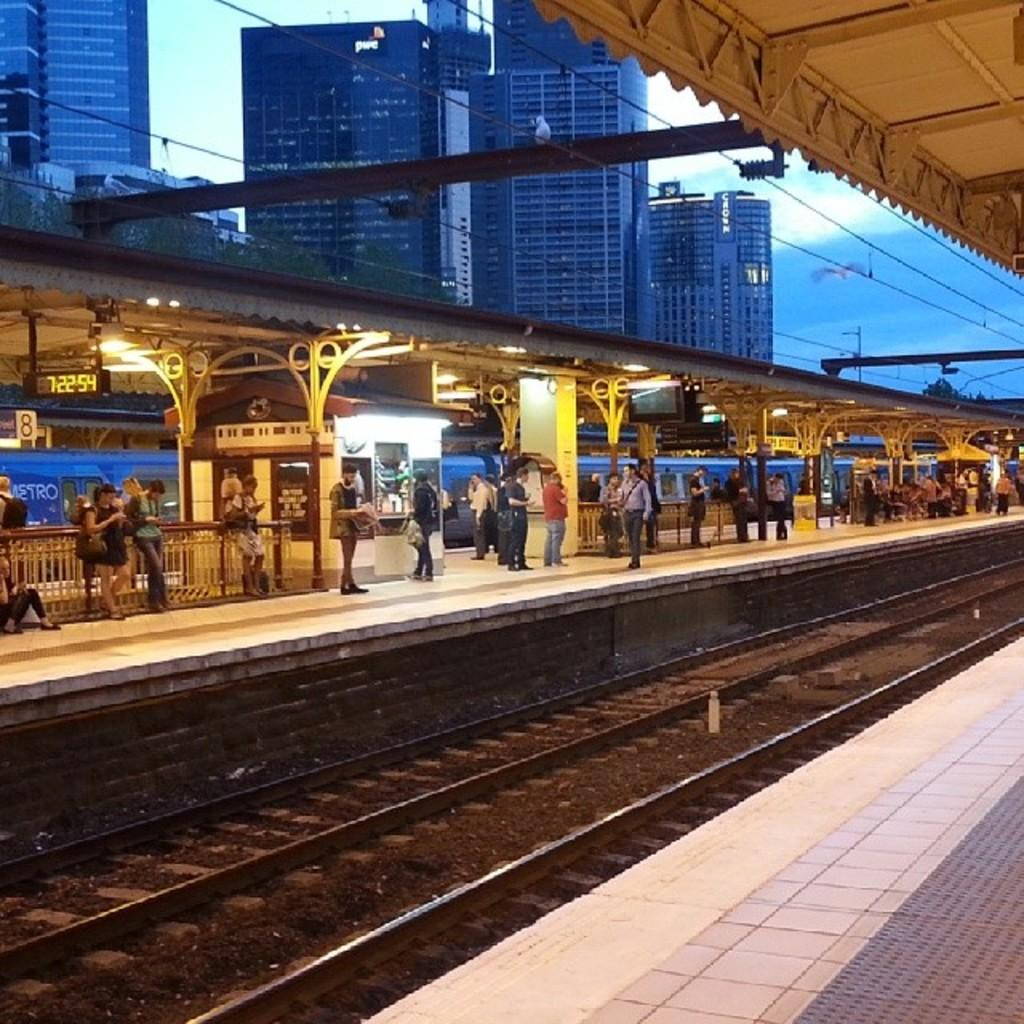How many people are in the image? There is a group of people in the image, but the exact number cannot be determined from the provided facts. What are the people in the image doing? Some people are seated, while others are standing. What can be seen in the background of the image? There are tracks, buildings, cables, and lights visible in the image. What might be used for illumination in the image? Lights are visible in the image. What type of button can be seen being stretched in the image? There is no button present in the image, and therefore no such activity can be observed. 